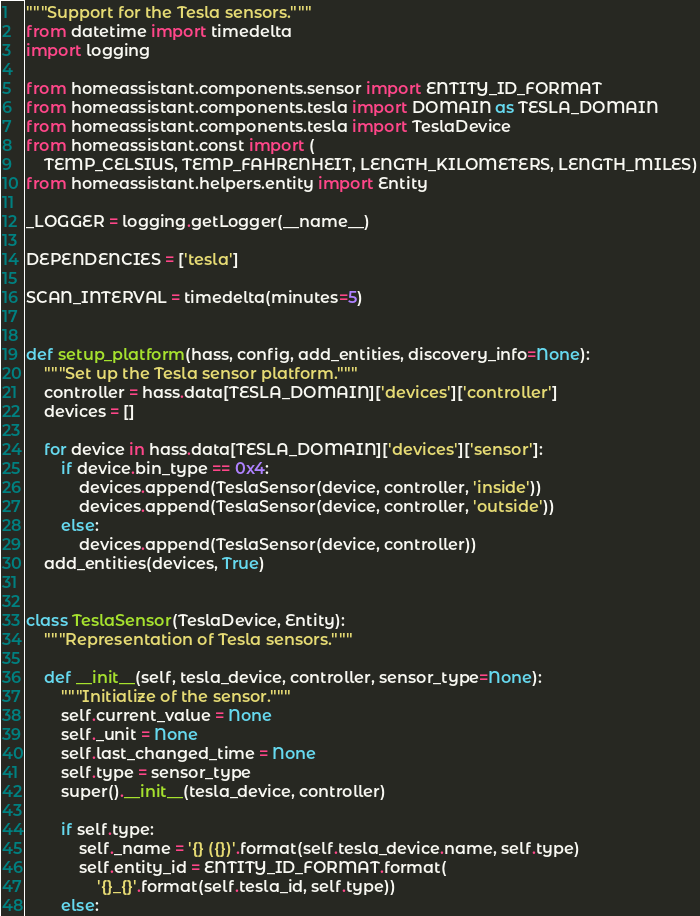<code> <loc_0><loc_0><loc_500><loc_500><_Python_>"""Support for the Tesla sensors."""
from datetime import timedelta
import logging

from homeassistant.components.sensor import ENTITY_ID_FORMAT
from homeassistant.components.tesla import DOMAIN as TESLA_DOMAIN
from homeassistant.components.tesla import TeslaDevice
from homeassistant.const import (
    TEMP_CELSIUS, TEMP_FAHRENHEIT, LENGTH_KILOMETERS, LENGTH_MILES)
from homeassistant.helpers.entity import Entity

_LOGGER = logging.getLogger(__name__)

DEPENDENCIES = ['tesla']

SCAN_INTERVAL = timedelta(minutes=5)


def setup_platform(hass, config, add_entities, discovery_info=None):
    """Set up the Tesla sensor platform."""
    controller = hass.data[TESLA_DOMAIN]['devices']['controller']
    devices = []

    for device in hass.data[TESLA_DOMAIN]['devices']['sensor']:
        if device.bin_type == 0x4:
            devices.append(TeslaSensor(device, controller, 'inside'))
            devices.append(TeslaSensor(device, controller, 'outside'))
        else:
            devices.append(TeslaSensor(device, controller))
    add_entities(devices, True)


class TeslaSensor(TeslaDevice, Entity):
    """Representation of Tesla sensors."""

    def __init__(self, tesla_device, controller, sensor_type=None):
        """Initialize of the sensor."""
        self.current_value = None
        self._unit = None
        self.last_changed_time = None
        self.type = sensor_type
        super().__init__(tesla_device, controller)

        if self.type:
            self._name = '{} ({})'.format(self.tesla_device.name, self.type)
            self.entity_id = ENTITY_ID_FORMAT.format(
                '{}_{}'.format(self.tesla_id, self.type))
        else:</code> 